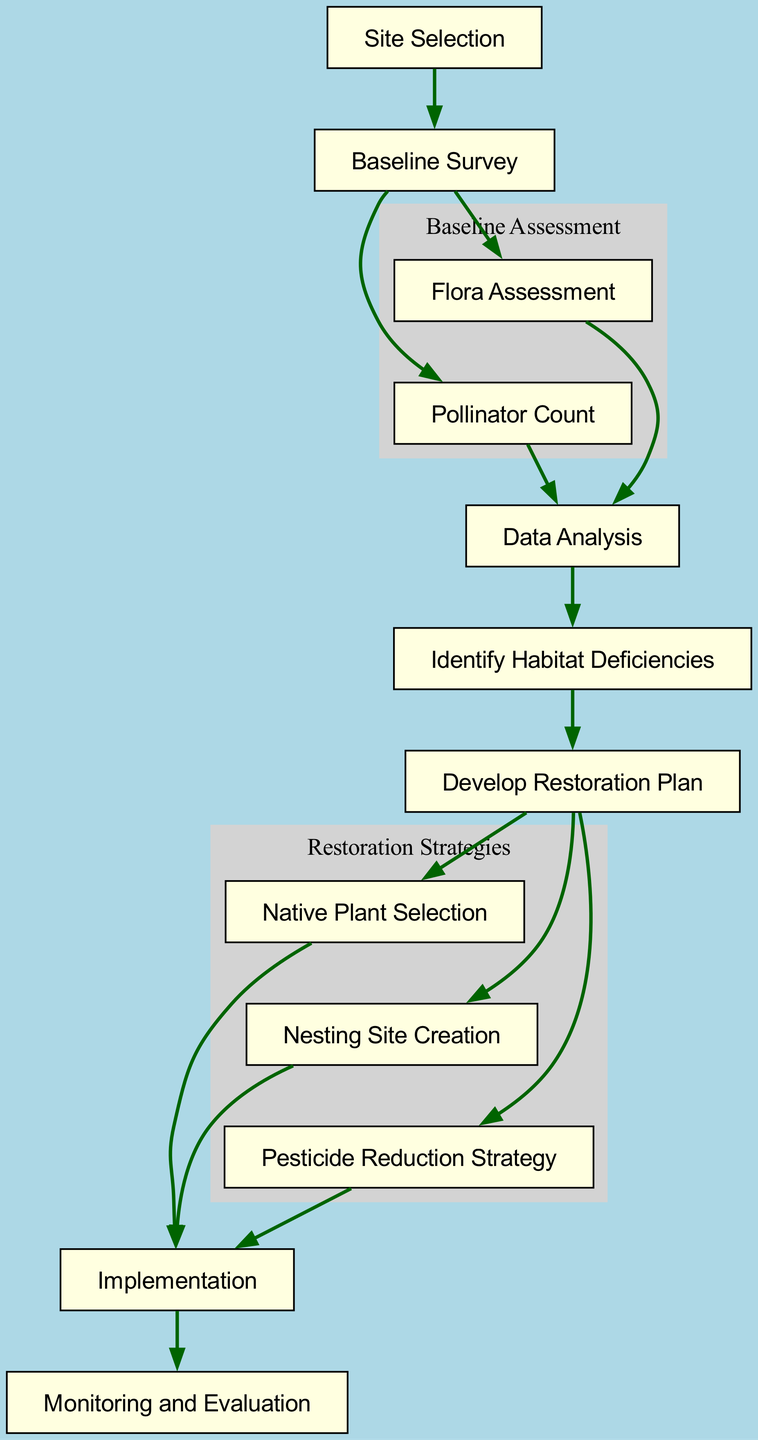What is the first step in the flow chart? The flow chart indicates that "Site Selection" is the first step as it is the node with no incoming edges.
Answer: Site Selection How many main steps are in the flow chart? By counting the unique nodes connected in the flow chart, there are twelve main steps represented.
Answer: 12 What step follows the "Baseline Survey"? After "Baseline Survey," the next steps are "Flora Assessment" and "Pollinator Count," but since the question asks for the direct successor, the correct answer is "Flora Assessment" based on the flow.
Answer: Flora Assessment Which nodes are part of the "Restoration Strategies" cluster? The nodes grouped in the "Restoration Strategies" cluster are "Native Plant Selection," "Nesting Site Creation," and "Pesticide Reduction Strategy," as shown in their grouping subgraph.
Answer: Native Plant Selection, Nesting Site Creation, Pesticide Reduction Strategy What occurs after "Identify Habitat Deficiencies"? The diagram shows that after "Identify Habitat Deficiencies," the next node is "Develop Restoration Plan."
Answer: Develop Restoration Plan Which two assessments occur simultaneously after the "Baseline Survey"? The "Flora Assessment" and "Pollinator Count" occur simultaneously after completing the "Baseline Survey," as both nodes branch out from it.
Answer: Flora Assessment and Pollinator Count How many nodes lead to "Implementation"? Only one node, "Restoration Plan," directly leads to "Implementation" as per the structure of the flow chart.
Answer: 1 What is the final step indicated in the flow chart? According to the diagram, the last step is "Monitoring and Evaluation," which follows "Implementation."
Answer: Monitoring and Evaluation What does the arrow direction indicate in the flow chart? The arrow direction signifies the flow of the process, showing the sequential steps to follow from one node to the next until the end.
Answer: Sequential steps flow 